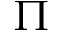<formula> <loc_0><loc_0><loc_500><loc_500>\Pi</formula> 